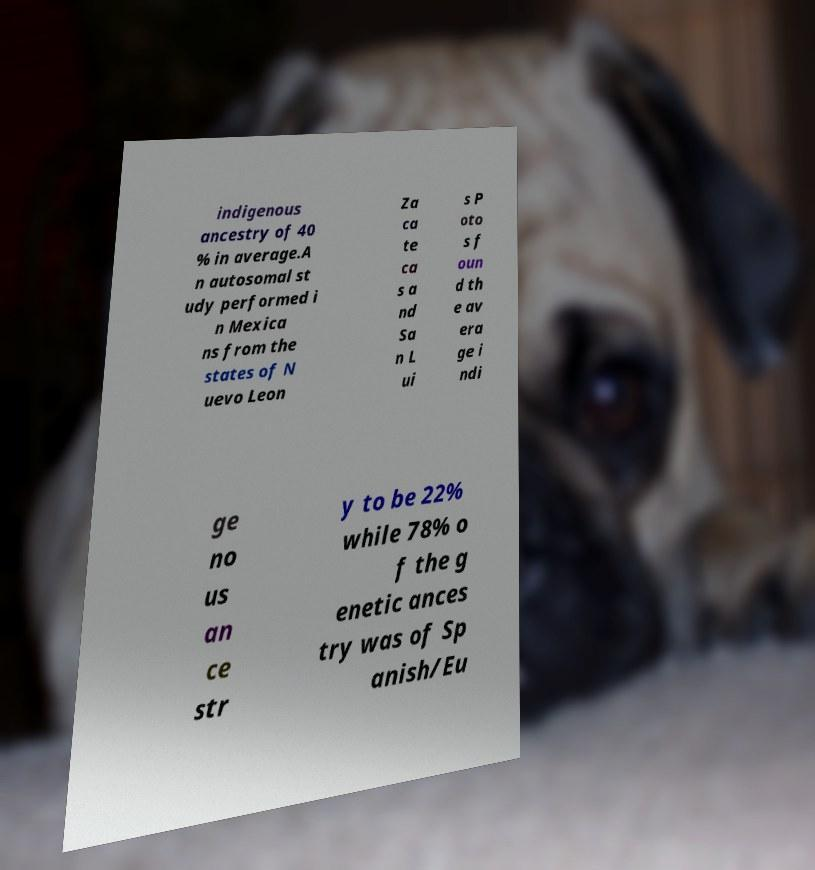Can you accurately transcribe the text from the provided image for me? indigenous ancestry of 40 % in average.A n autosomal st udy performed i n Mexica ns from the states of N uevo Leon Za ca te ca s a nd Sa n L ui s P oto s f oun d th e av era ge i ndi ge no us an ce str y to be 22% while 78% o f the g enetic ances try was of Sp anish/Eu 